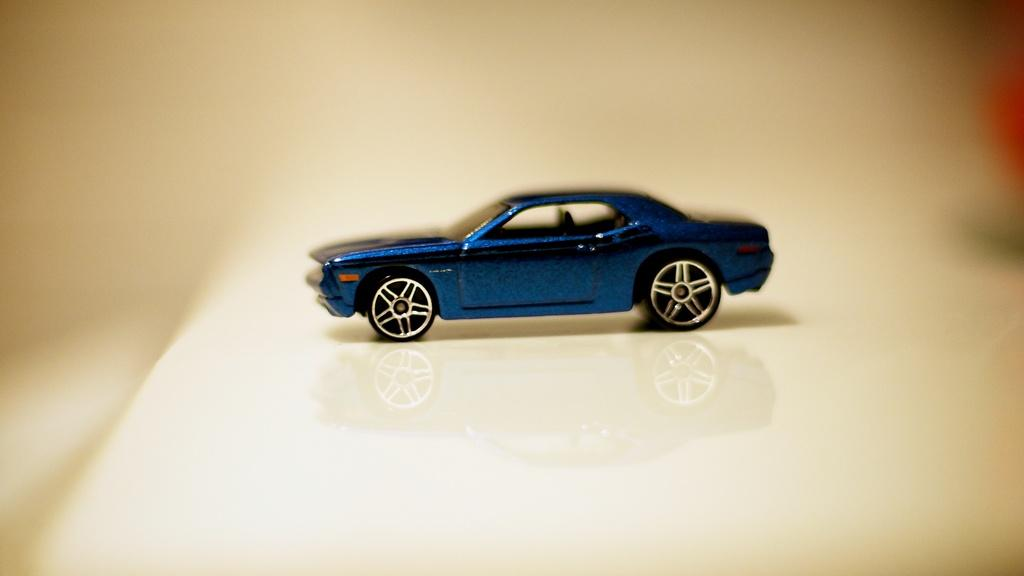What type of vehicle is in the image? There is a blue car in the image. How is the car being reflected in the image? The car is reflecting on the floor. Can you describe the background of the image? The background of the image is blurry. What statement does the son make about the car in the image? There is no son present in the image, and therefore no statement can be attributed to him. 